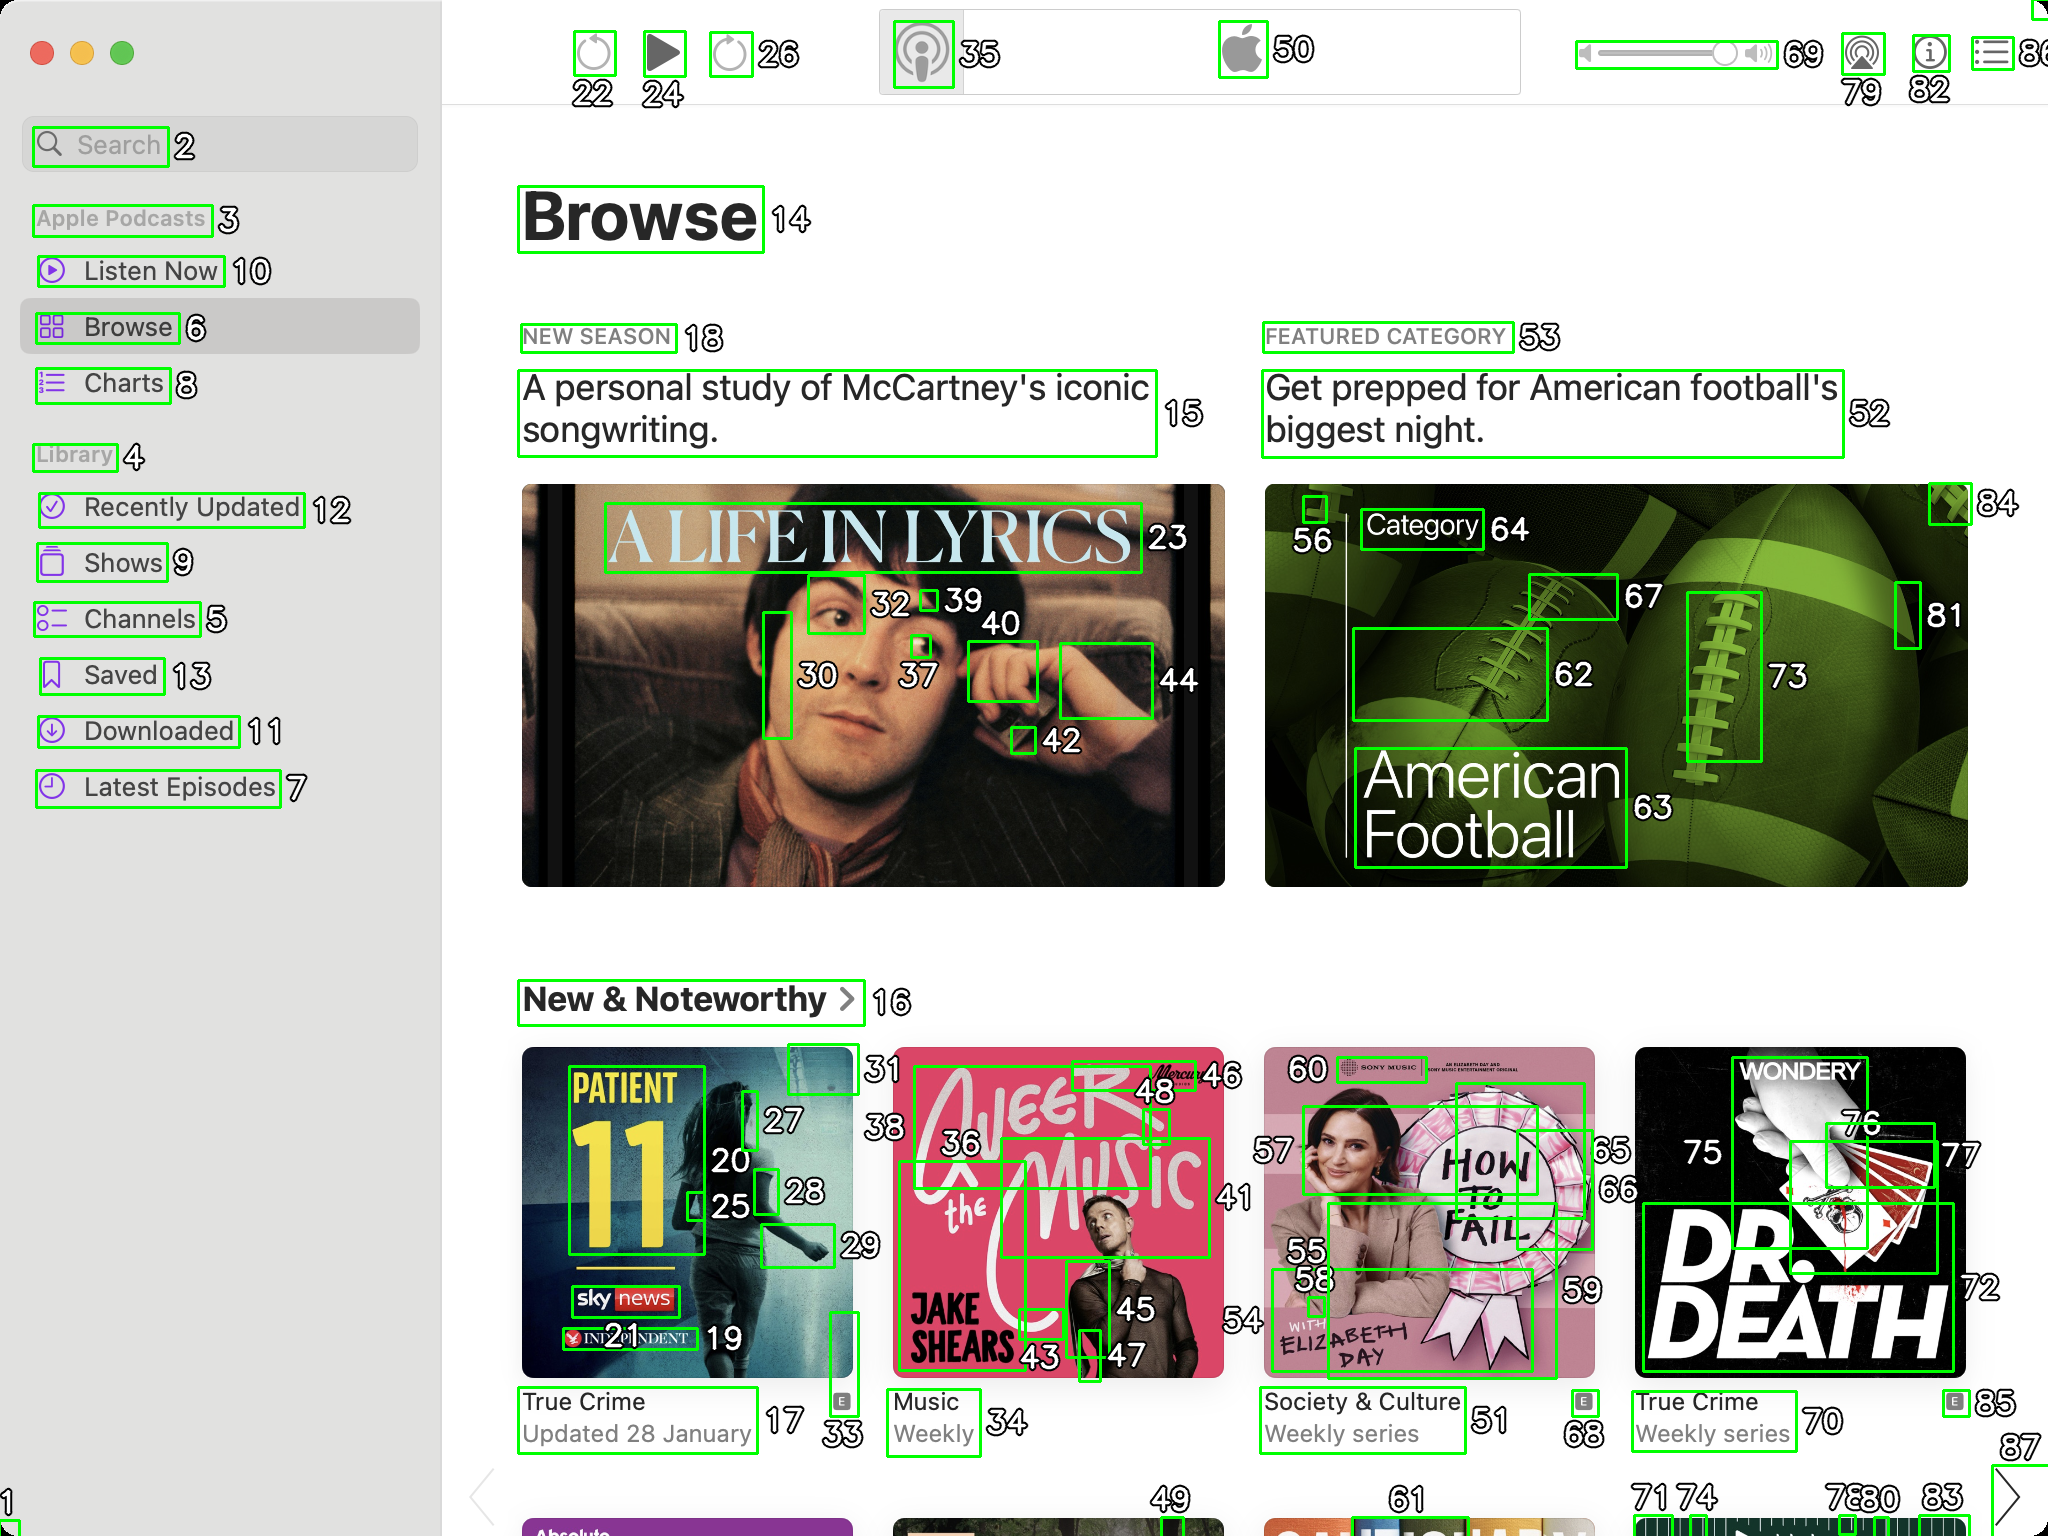You’re an expert in image processing and UI design, known for your meticulous eye when it comes to segmenting components accurately in UI screenshots. Your next task involves fixing incorrectly segmented components in UI screenshots.

Given a UI screenshot of Apple Podcasts application on MacOS with segmented components bordered in green boxes, alongside each box is an ID (a white number with a black stroke). The ID are in range 1 to 88. Some components are segmented incorrectly and need to be merged. Your task is to provide the corrected segments in JSON format.

Remember to merge only those components that are originally parts of the same entity but were wrongly split during segmentation. Keep the IDs intact to indicate the corrected grouping.

Also, analize what you have merged and give a description of what that UI component represents.

For example, if ID 5 should have included components 1, 4, 5, 9, 12, and 13 within it due to incorrect segmentation, your JSON output should be:

```json
[
	{
		"id": 5,
		"components": [1, 4, 5, 9, 12, 13],
		"description": "The podcast image"
	}
]

```

As the output provide only JSON string and nothing else. ```json
[
    {
        "id": 1,
        "components": [1, 2],
        "description": "Search bar"
    },
    {
        "id": 5,
        "components": [5, 6],
        "description": "Browse button"
    },
    {
        "id": 15,
        "components": [15, 18],
        "description": "Section 'New Season'"
    },
    {
        "id": 44,
        "components": [39, 40, 44],
        "description": "Podcast image and controls"
    },
    {
        "id": 52,
        "components": [52, 53],
        "description": "Section 'Featured Category'"
    },
    {
        "id": 62,
        "components": [62, 63, 64],
        "description": "American Football category"
    },
    {
        "id": 27,
        "components": [20, 25, 27, 28],
        "description": "First podcast in 'New & Noteworthy'"
    },
    {
        "id": 46,
        "components": [36, 43, 45, 46],
        "description": "Second podcast in 'New & Noteworthy'"
    },
    {
        "id": 59,
        "components": [55, 56, 58, 59],
        "description": "Third podcast in 'New & Noteworthy'"
    },
    {
        "id": 75,
        "components": [68, 75, 76, 77],
        "description": "Fourth podcast in 'New & Noteworthy'"
    }
]
``` 